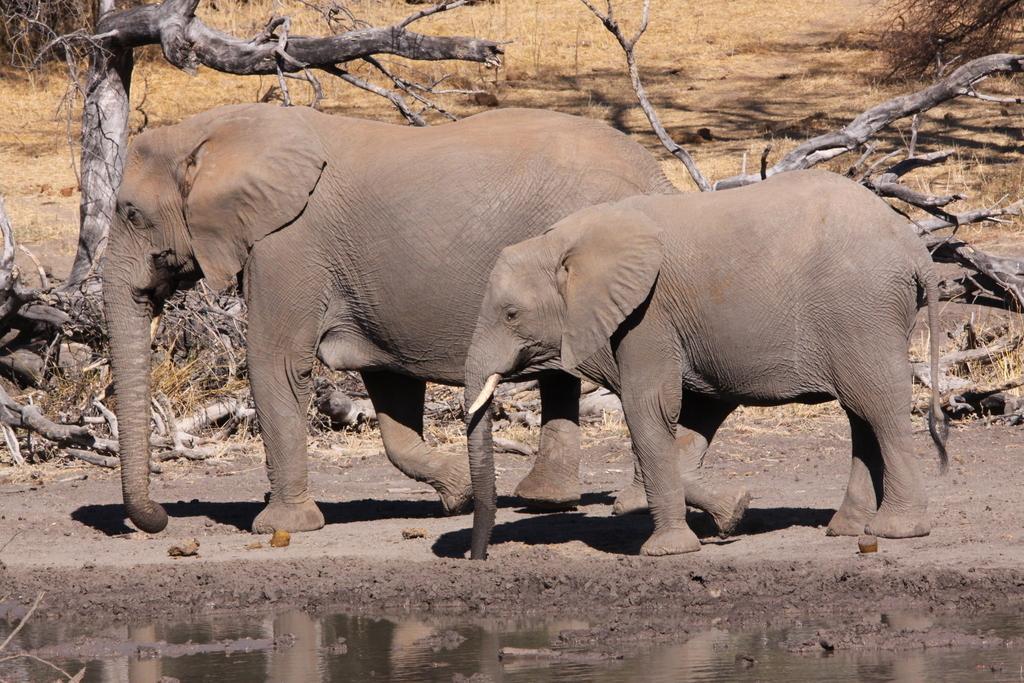Could you give a brief overview of what you see in this image? In this picture there are two elephants were walking on the ground. In the back I can see the tree and woods. At the top I can see the grass. At the bottom I can see the water. 